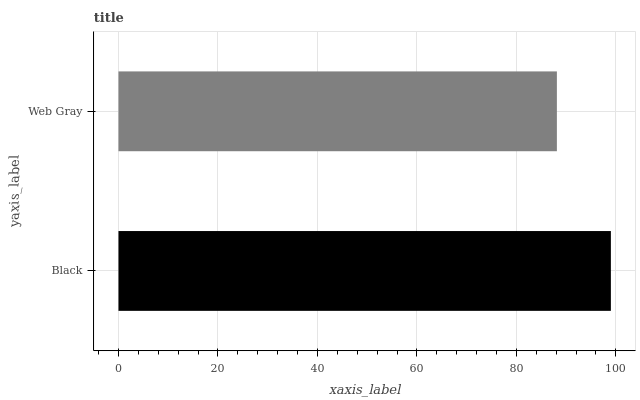Is Web Gray the minimum?
Answer yes or no. Yes. Is Black the maximum?
Answer yes or no. Yes. Is Web Gray the maximum?
Answer yes or no. No. Is Black greater than Web Gray?
Answer yes or no. Yes. Is Web Gray less than Black?
Answer yes or no. Yes. Is Web Gray greater than Black?
Answer yes or no. No. Is Black less than Web Gray?
Answer yes or no. No. Is Black the high median?
Answer yes or no. Yes. Is Web Gray the low median?
Answer yes or no. Yes. Is Web Gray the high median?
Answer yes or no. No. Is Black the low median?
Answer yes or no. No. 